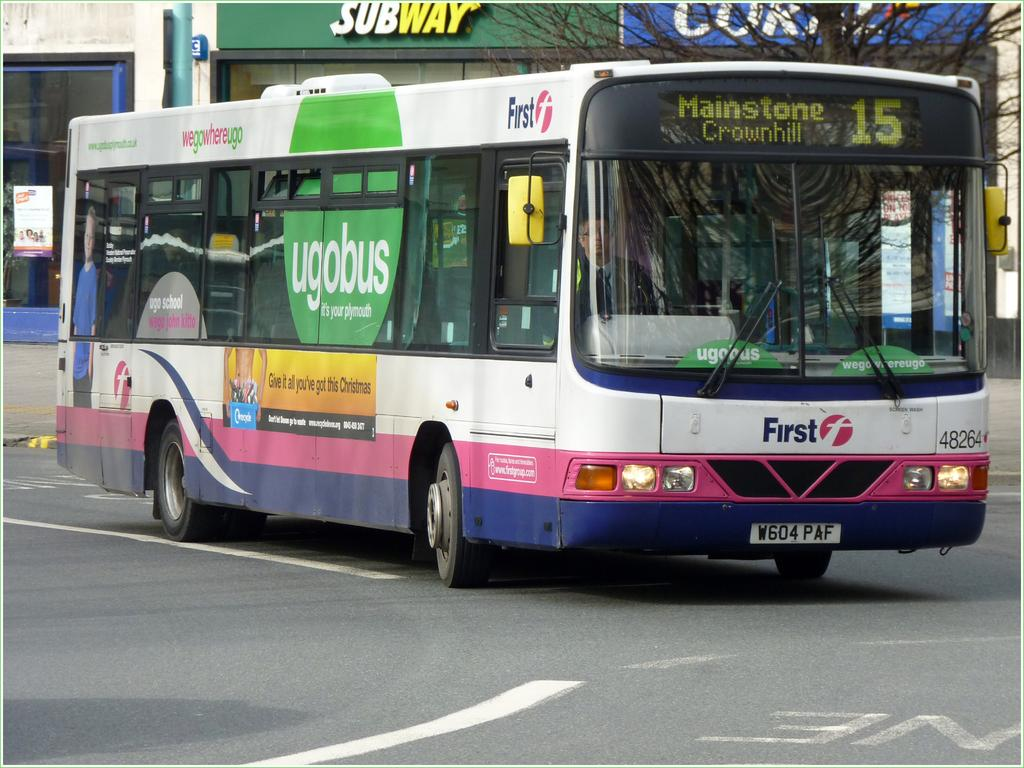Provide a one-sentence caption for the provided image. a bus heading to Mainstone with a Subway behind. 